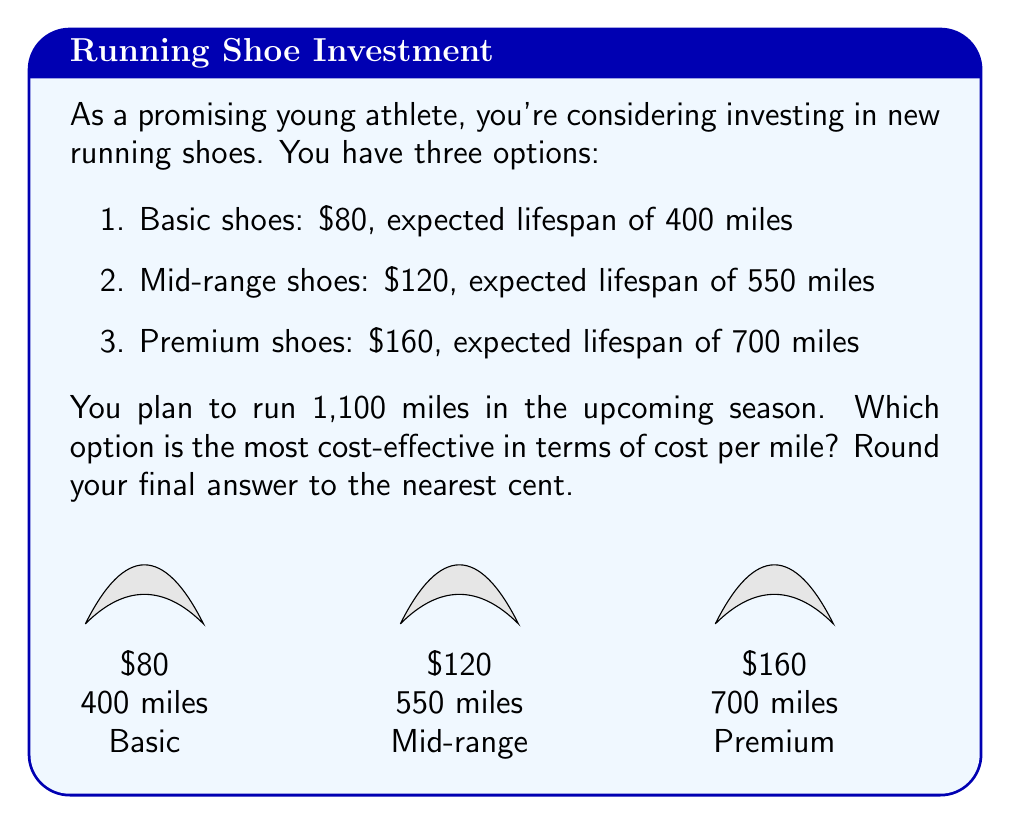What is the answer to this math problem? Let's approach this step-by-step:

1) First, we need to calculate how many pairs of each type of shoe we would need for 1,100 miles:

   Basic: $\frac{1100}{400} = 2.75$ pairs (round up to 3)
   Mid-range: $\frac{1100}{550} = 2$ pairs
   Premium: $\frac{1100}{700} = 1.57$ pairs (round up to 2)

2) Now, let's calculate the total cost for each option:

   Basic: $3 \times $80 = $240
   Mid-range: $2 \times $120 = $240
   Premium: $2 \times $160 = $320

3) To find the cost per mile, we divide the total cost by 1,100 miles:

   Basic: $\frac{240}{1100} = $0.2182 per mile
   Mid-range: $\frac{240}{1100} = $0.2182 per mile
   Premium: $\frac{320}{1100} = $0.2909 per mile

4) Rounding to the nearest cent:

   Basic: $0.22 per mile
   Mid-range: $0.22 per mile
   Premium: $0.29 per mile

Therefore, both the basic and mid-range shoes are equally cost-effective at $0.22 per mile, while the premium shoes are less cost-effective at $0.29 per mile.
Answer: $0.22 per mile (basic or mid-range) 